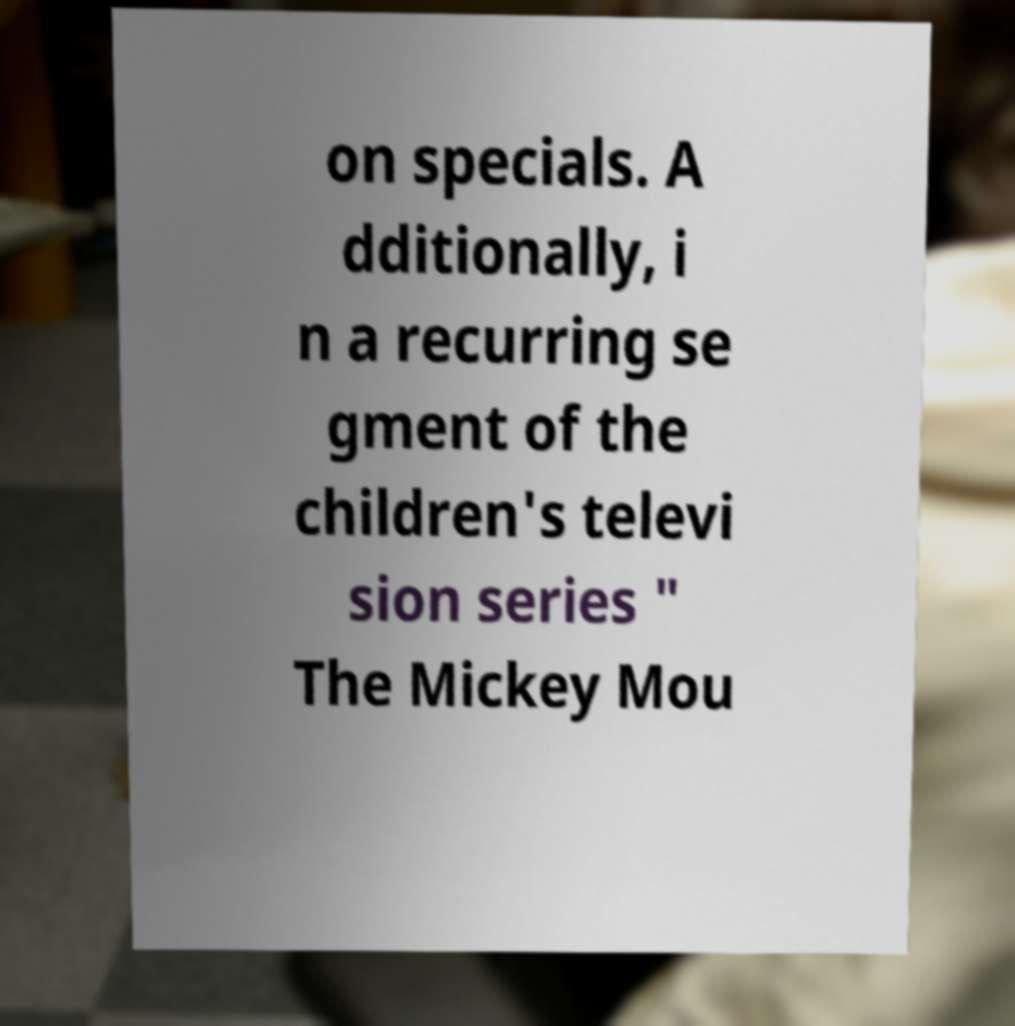I need the written content from this picture converted into text. Can you do that? on specials. A dditionally, i n a recurring se gment of the children's televi sion series " The Mickey Mou 